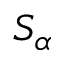Convert formula to latex. <formula><loc_0><loc_0><loc_500><loc_500>S _ { \alpha }</formula> 